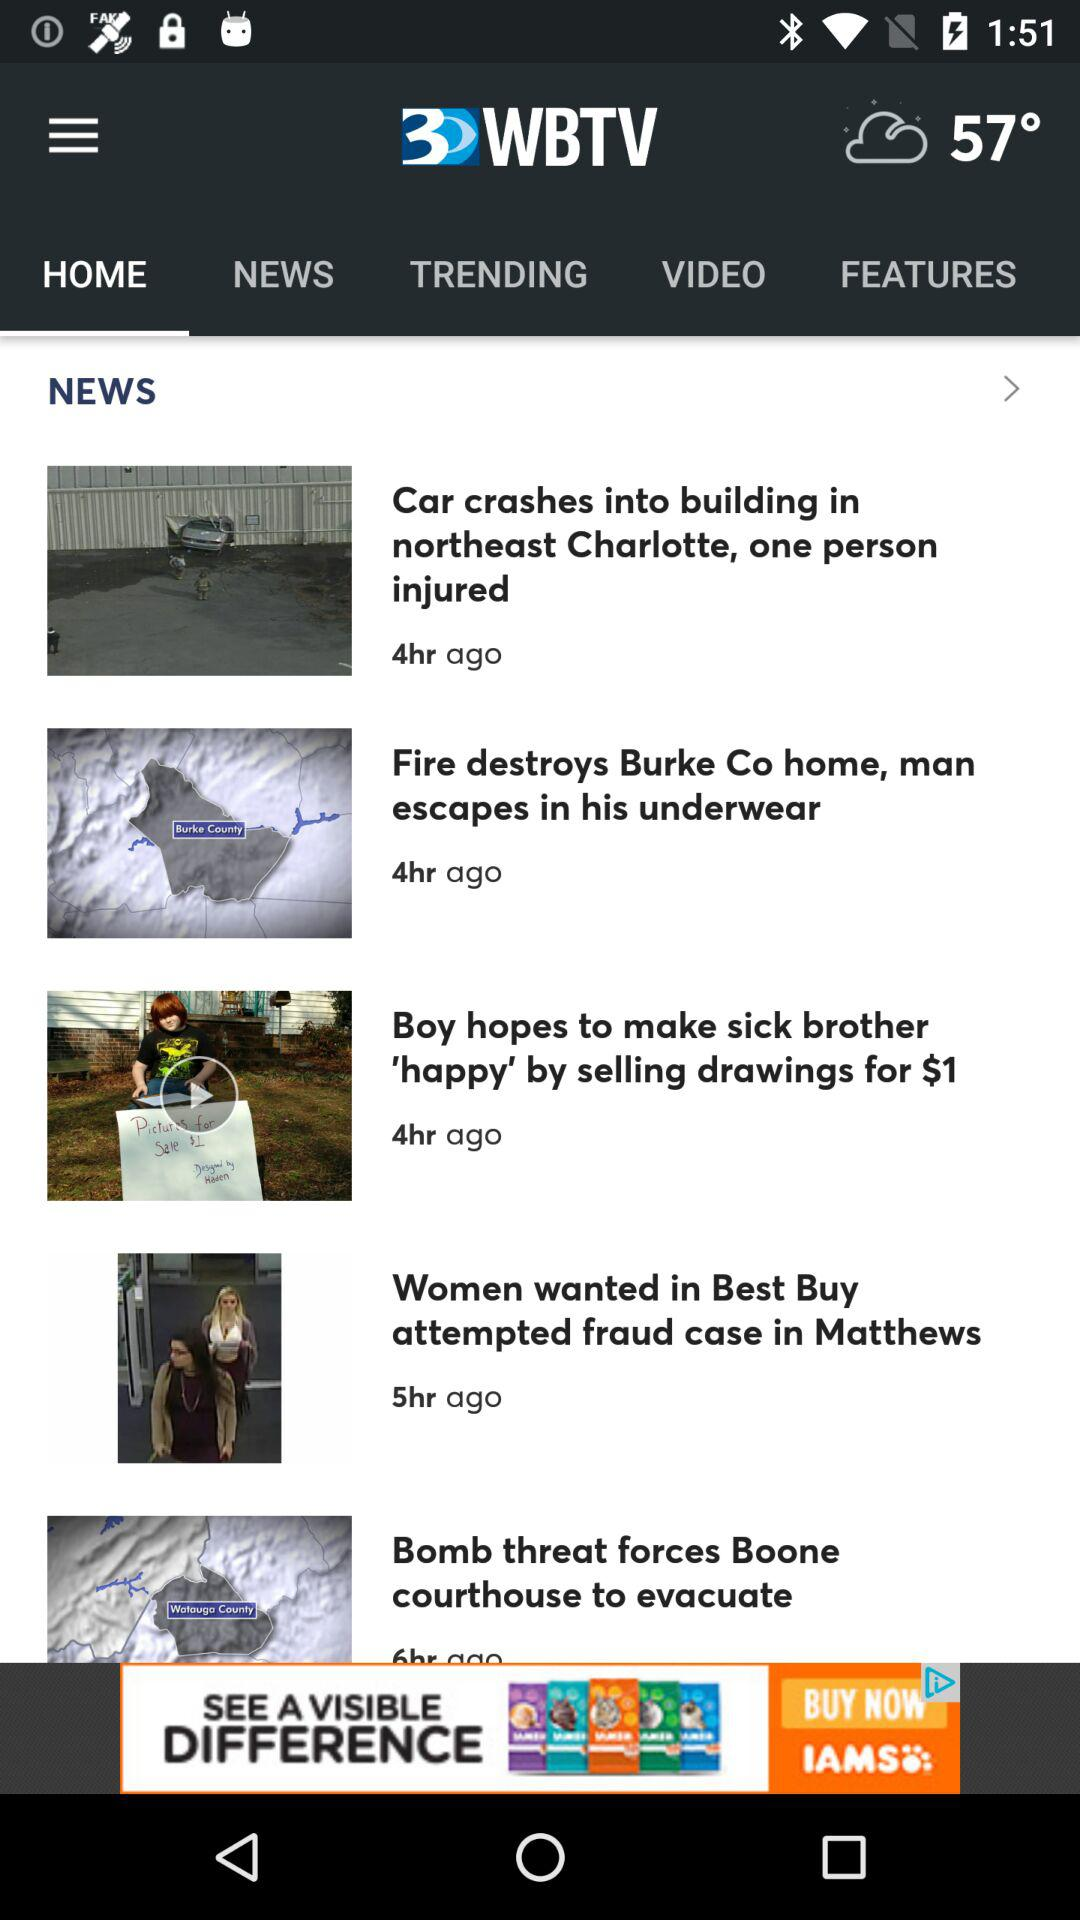What is the application name? The application name is "WBTV". 